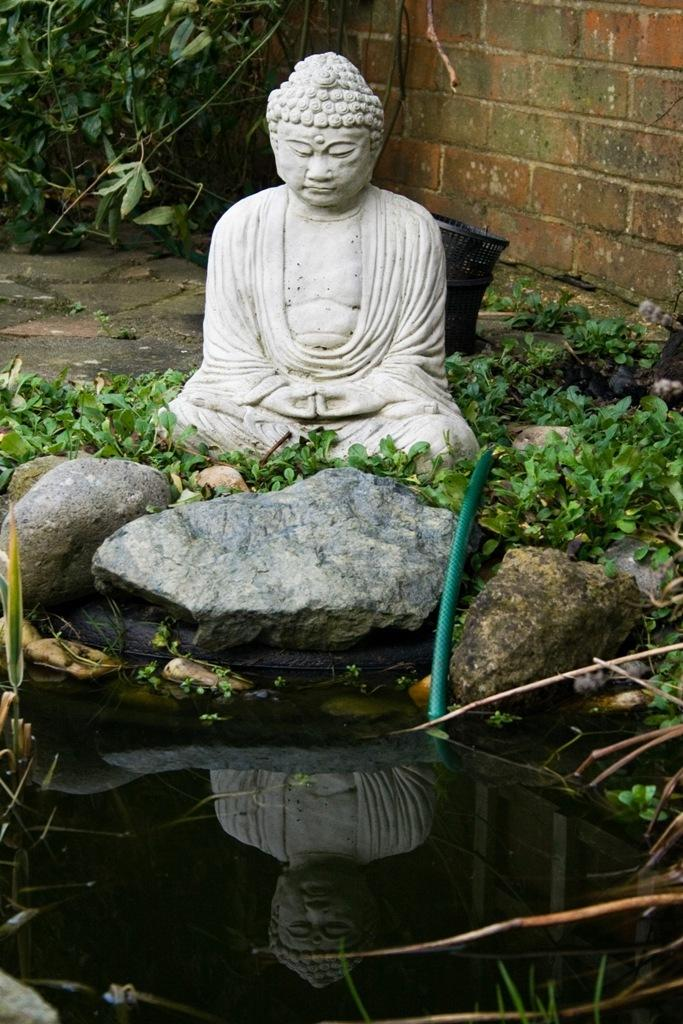What is the main subject in the image? There is a statue in the image. What type of material can be seen in the image? There are stones in the image. What object is present that might be used for transporting water or other liquids? There is a pipe in the image. Can you describe the liquid visible in the image? There is water visible in the image. What type of storage or holding objects can be seen in the image? There are containers in the image. What type of structure is present in the image? There is a wall in the image. Can you see any seeds growing near the seashore in the image? There is no seashore or seeds present in the image. 